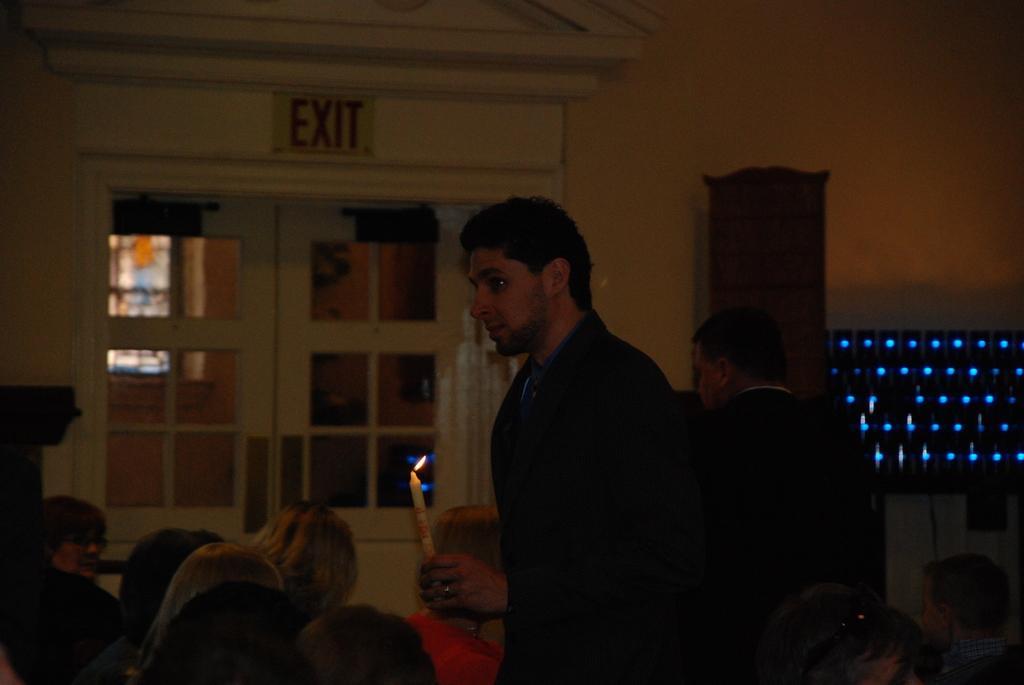Could you give a brief overview of what you see in this image? There is one person standing and wearing a black color blazer and holding a candle at the bottom of this image. There are some persons in the background. There is a wall as we can see in the middle of this image. There is a door on the left side of this image. There is a exit board at the top side to this door. 